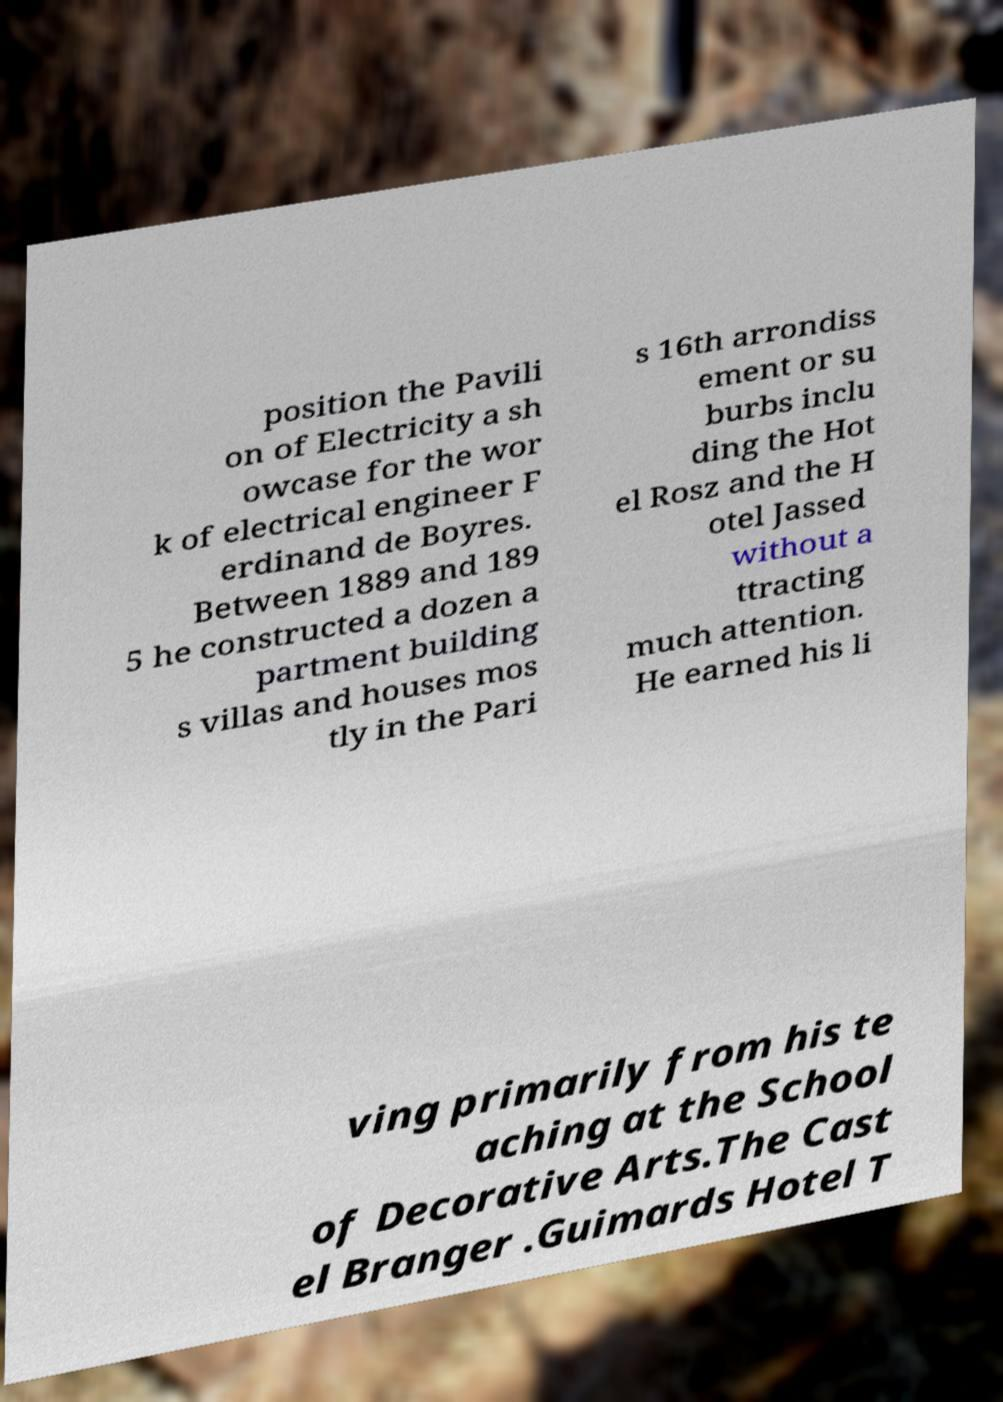I need the written content from this picture converted into text. Can you do that? position the Pavili on of Electricity a sh owcase for the wor k of electrical engineer F erdinand de Boyres. Between 1889 and 189 5 he constructed a dozen a partment building s villas and houses mos tly in the Pari s 16th arrondiss ement or su burbs inclu ding the Hot el Rosz and the H otel Jassed without a ttracting much attention. He earned his li ving primarily from his te aching at the School of Decorative Arts.The Cast el Branger .Guimards Hotel T 